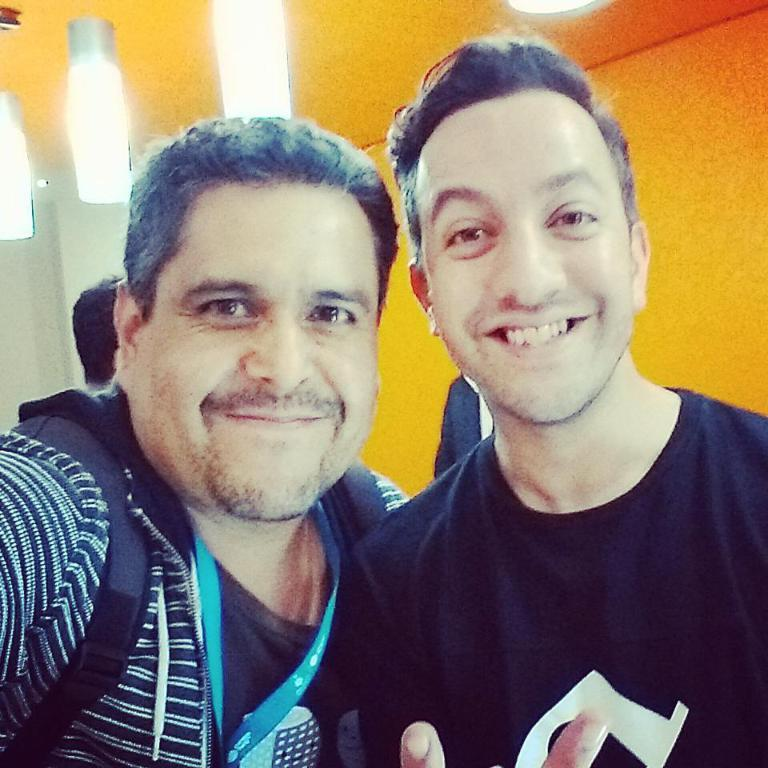How many people are in the image? There are people in the image, but the exact number is not specified. What is one person carrying in the image? One person is wearing a backpack in the image. What can be seen in the background of the image? There is a wall visible in the background of the image. What type of illumination is present in the image? There are lights in the image. What type of grape is being sung about in the image? There is no mention of grapes or singing in the image; it features people, a backpack, a wall, and lights. 